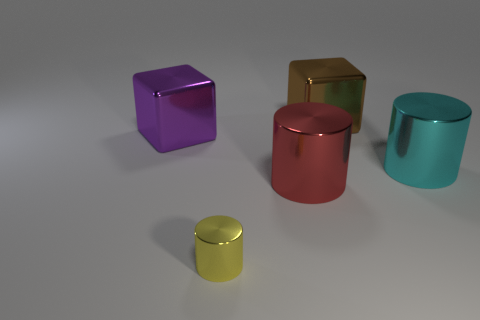What number of objects are either shiny objects or cubes that are to the left of the small yellow shiny cylinder?
Your answer should be compact. 5. What size is the metal block that is to the right of the big block that is left of the big red shiny cylinder?
Make the answer very short. Large. Are there the same number of large brown cubes that are right of the brown metal object and metallic objects that are behind the purple shiny object?
Give a very brief answer. No. Are there any purple metal blocks behind the block that is in front of the brown shiny block?
Provide a succinct answer. No. There is a purple object that is made of the same material as the large brown thing; what is its shape?
Ensure brevity in your answer.  Cube. Are there any other things that have the same color as the small thing?
Make the answer very short. No. The large cube that is left of the large metal thing that is in front of the large cyan thing is made of what material?
Your response must be concise. Metal. Is there another brown metal thing of the same shape as the tiny thing?
Give a very brief answer. No. How many other objects are the same shape as the big cyan thing?
Your response must be concise. 2. What shape is the object that is to the right of the big purple metallic cube and left of the red cylinder?
Your answer should be compact. Cylinder. 